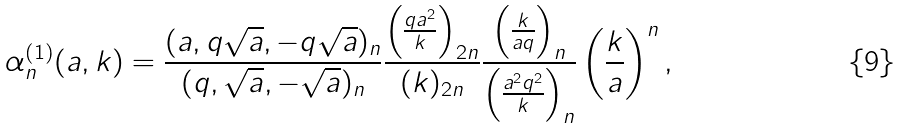Convert formula to latex. <formula><loc_0><loc_0><loc_500><loc_500>\alpha ^ { ( 1 ) } _ { n } ( a , k ) = \frac { ( a , q \sqrt { a } , - q \sqrt { a } ) _ { n } } { ( q , \sqrt { a } , - \sqrt { a } ) _ { n } } \frac { \left ( \frac { q a ^ { 2 } } { k } \right ) _ { 2 n } } { ( k ) _ { 2 n } } \frac { \left ( \frac { k } { a q } \right ) _ { n } } { \left ( \frac { a ^ { 2 } q ^ { 2 } } { k } \right ) _ { n } } \left ( \frac { k } { a } \right ) ^ { n } ,</formula> 